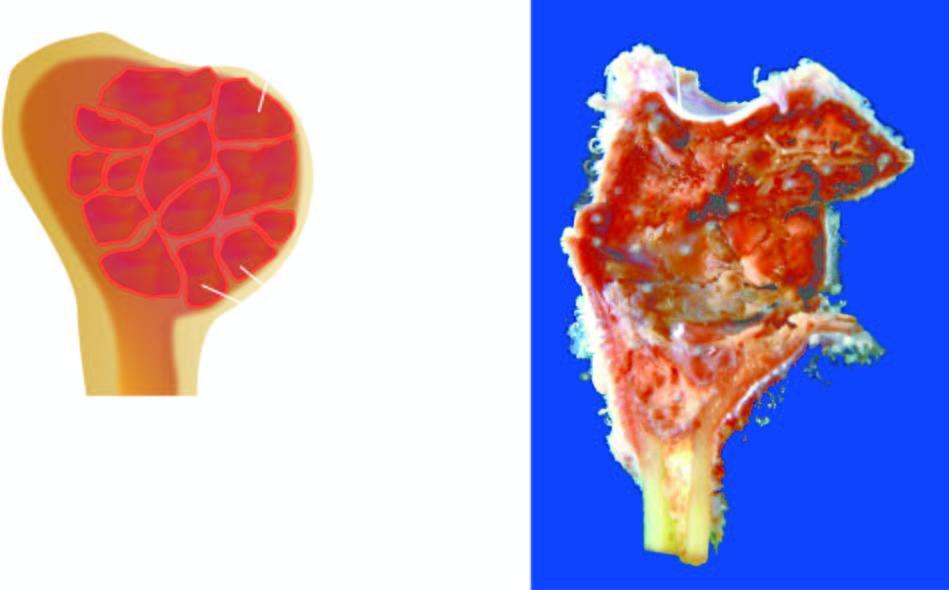s the inner wall of the cyst tan and haemorrhagic?
Answer the question using a single word or phrase. Yes 